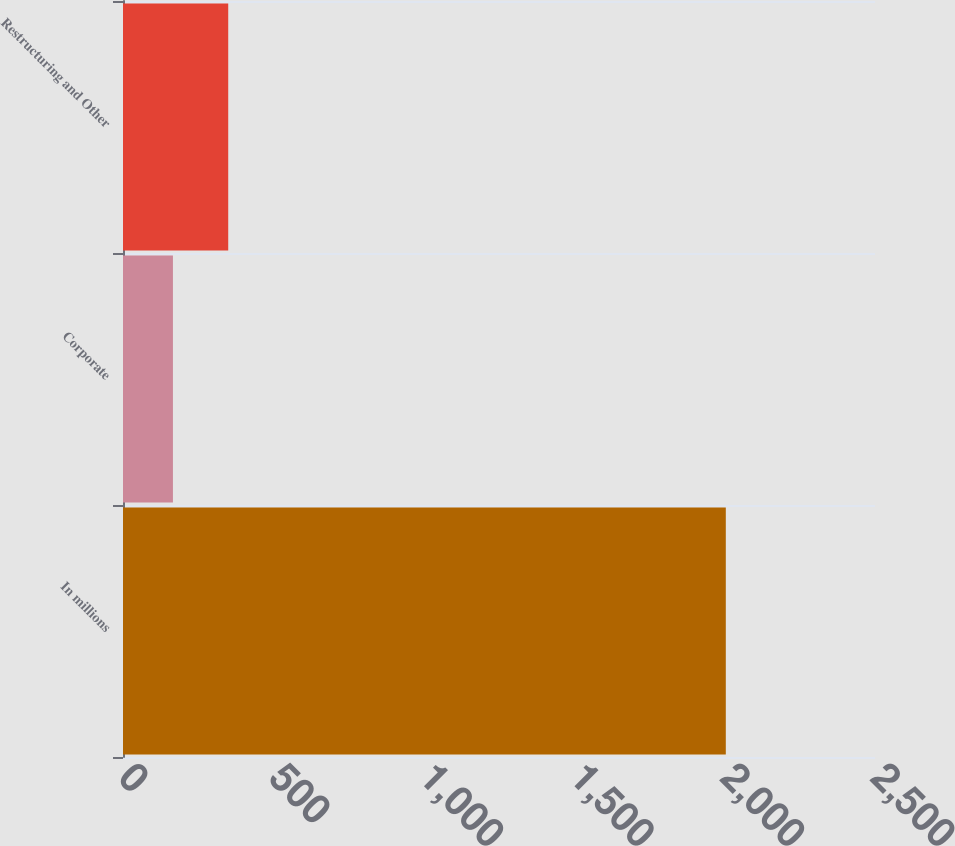Convert chart to OTSL. <chart><loc_0><loc_0><loc_500><loc_500><bar_chart><fcel>In millions<fcel>Corporate<fcel>Restructuring and Other<nl><fcel>2004<fcel>166<fcel>349.8<nl></chart> 